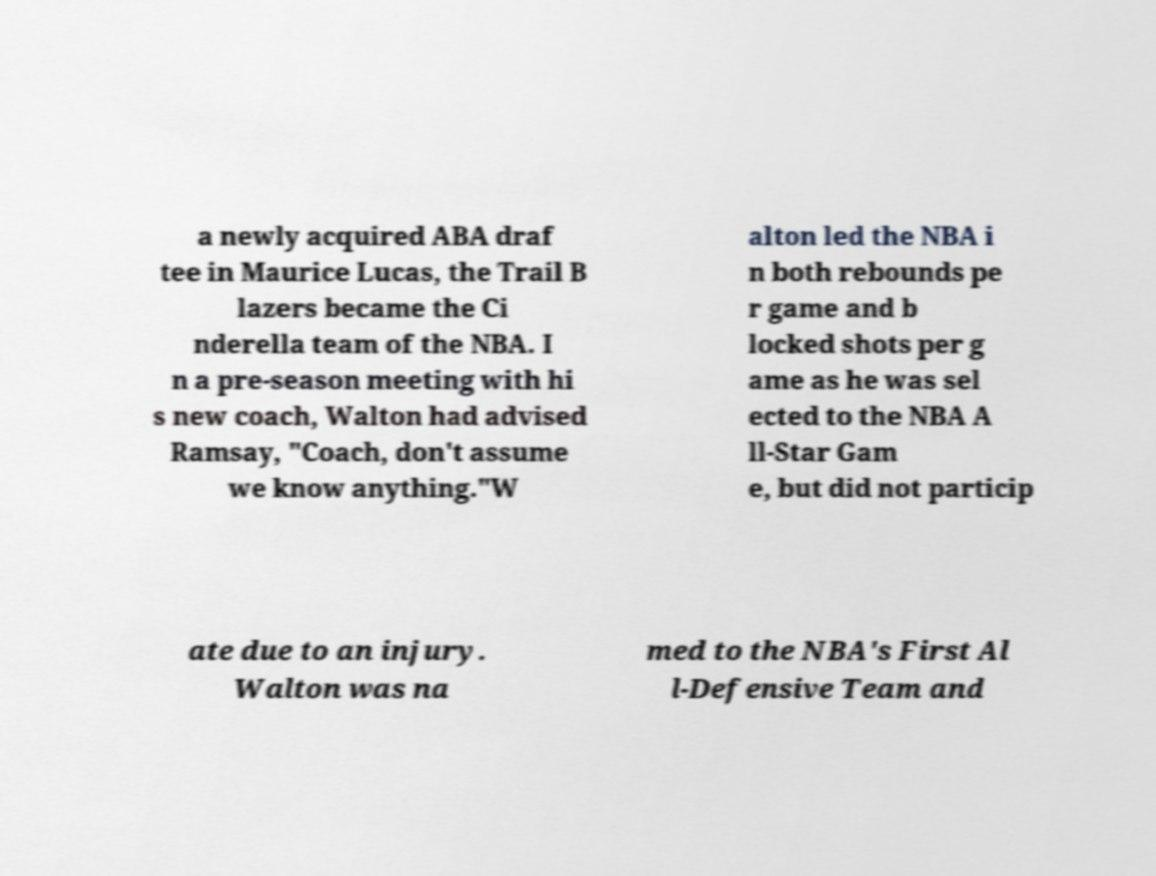There's text embedded in this image that I need extracted. Can you transcribe it verbatim? a newly acquired ABA draf tee in Maurice Lucas, the Trail B lazers became the Ci nderella team of the NBA. I n a pre-season meeting with hi s new coach, Walton had advised Ramsay, "Coach, don't assume we know anything."W alton led the NBA i n both rebounds pe r game and b locked shots per g ame as he was sel ected to the NBA A ll-Star Gam e, but did not particip ate due to an injury. Walton was na med to the NBA's First Al l-Defensive Team and 